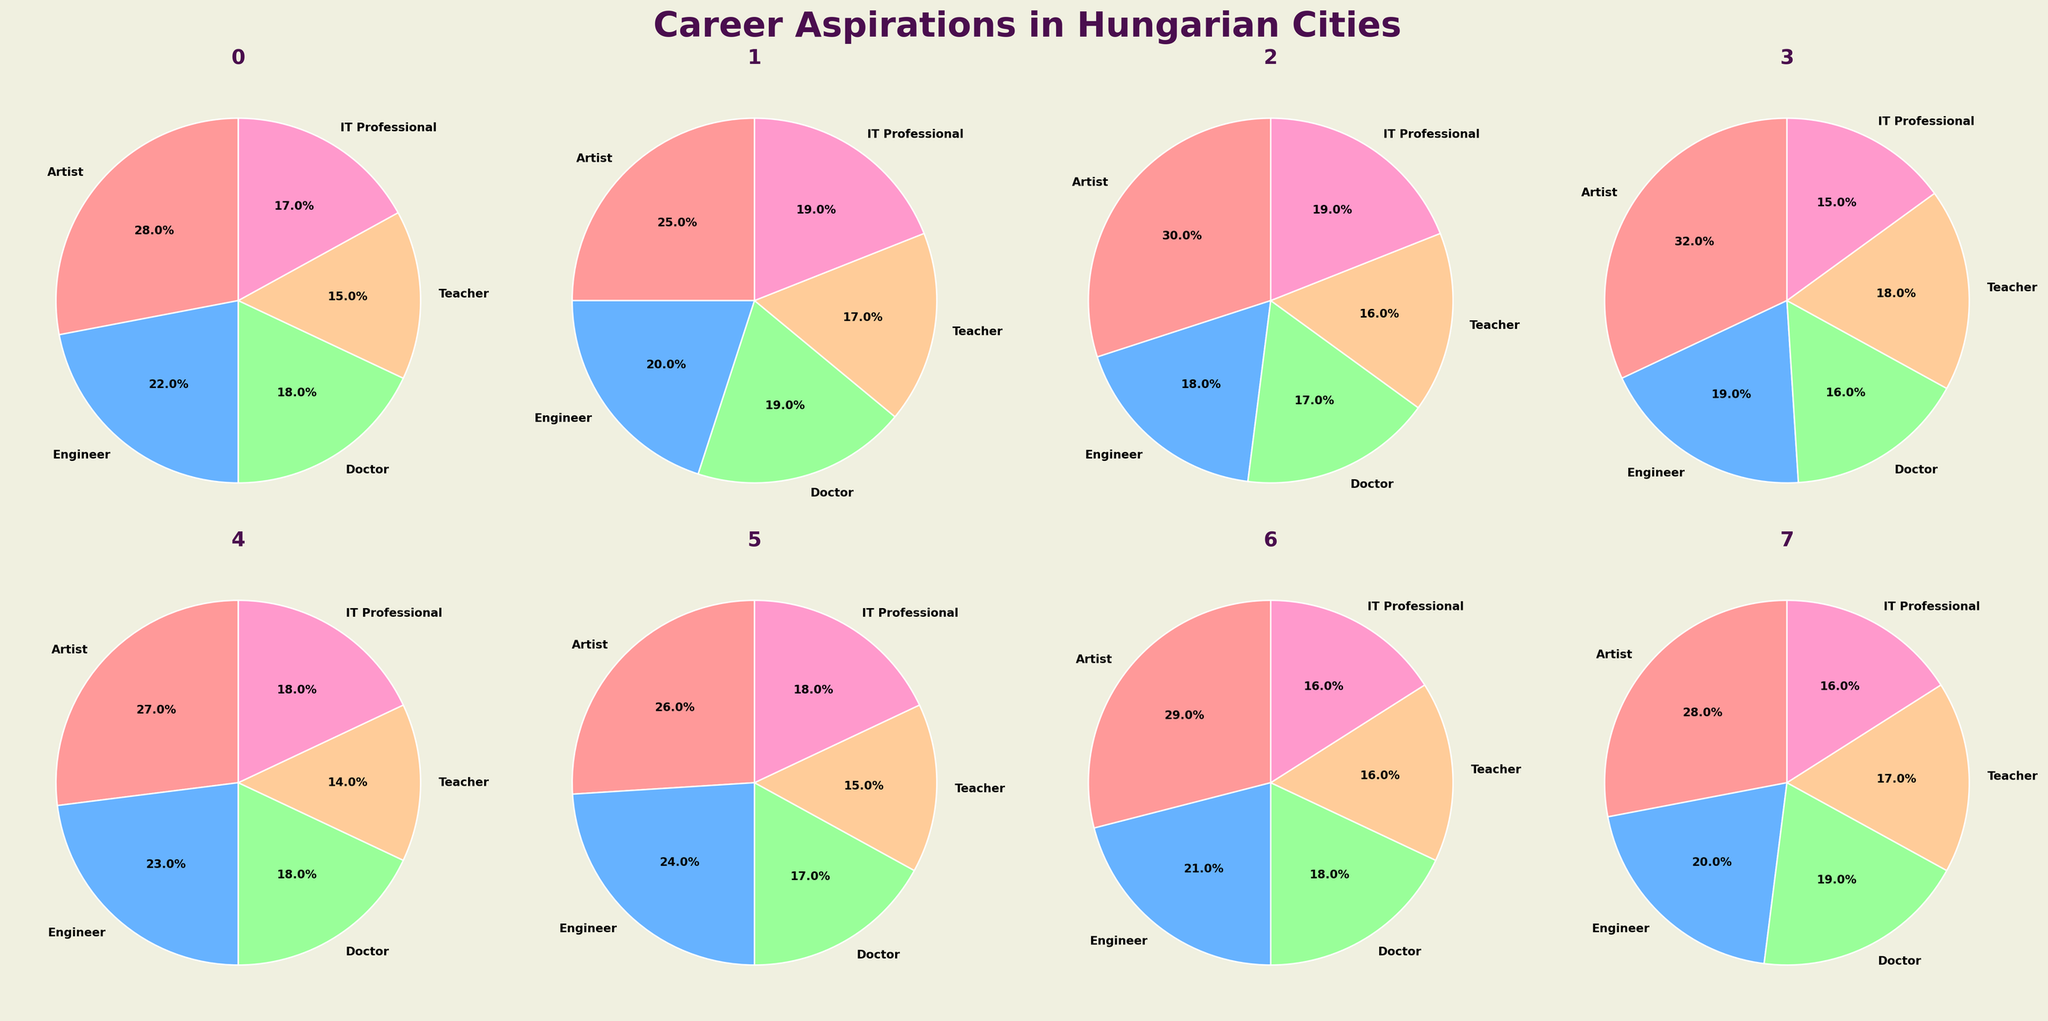which city has the highest percentage of students aspiring to be teachers? Look at each city’s pie chart and identify the slice representing 'Teacher'. Nyíregyháza and Pécs both have a significant teacher slice. Visually, we can compare the two and see which one is larger.
Answer: Pécs In which city do the most students aspire to be engineers? For each city, find the slice labeled 'Engineer' and visually compare the sizes. Győr has a noticeably larger 'Engineer' slice compared to other cities.
Answer: Miskolc Which career aspiration has the smallest percentage in Szeged? Inspect Szeged's pie chart and identify the smallest slice. Compare each slice to see which is the least significant.
Answer: Doctor How does the percentage of students aspiring to be artists in Miskolc compare to that in Budapest? Miskolc and Budapest both have slices for 'Artist'. Visually compare these slices to ascertain which one is larger or if they are equal.
Answer: Miskolc What is the combined percentage of students aspiring to be doctors and IT professionals in Debrecen? For Debrecen, sum the percentages of 'Doctor' and 'IT Professional' slices. These slices are 19% and 19%, respectively. Add them up (19 + 19 = 38).
Answer: 38% Which city has the most balanced distribution of career aspirations? Look at all the pie charts and identify the one where slices are most similar in size, indicating no single aspiration dominates. This requires visual comparison across cities.
Answer: Székesfehérvár Does any city have an equal number of students aspiring to be engineers and IT professionals? Identify cities where the pie slices for 'Engineer' and 'IT Professional' are of equal size. Compare these slices in each city's pie chart.
Answer: Budapest, Szeged If you combine the data from all cities, which career aspiration would be the most popular? Sum up the percentages or values for each career across all cities, then compare these totals to determine which is the highest. This may take some arithmetic if actual values are available.
Answer: Artist Which career aspiration has the smallest percentage in Debrecen? Look at Debrecen’s pie chart and visually identify the smallest slice. By comparing, the smallest slice can be identified.
Answer: Engineer 